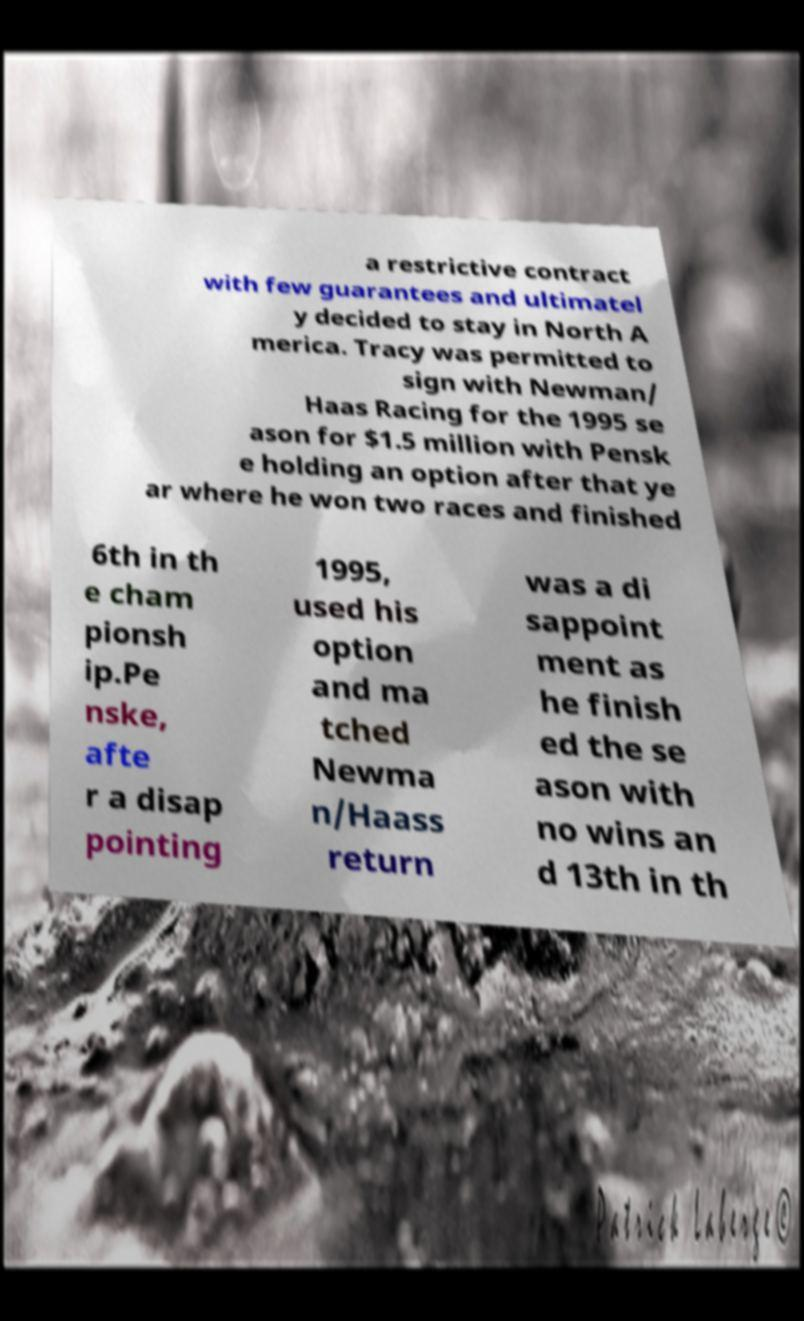Can you read and provide the text displayed in the image?This photo seems to have some interesting text. Can you extract and type it out for me? a restrictive contract with few guarantees and ultimatel y decided to stay in North A merica. Tracy was permitted to sign with Newman/ Haas Racing for the 1995 se ason for $1.5 million with Pensk e holding an option after that ye ar where he won two races and finished 6th in th e cham pionsh ip.Pe nske, afte r a disap pointing 1995, used his option and ma tched Newma n/Haass return was a di sappoint ment as he finish ed the se ason with no wins an d 13th in th 